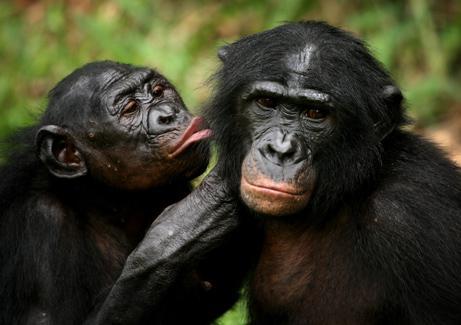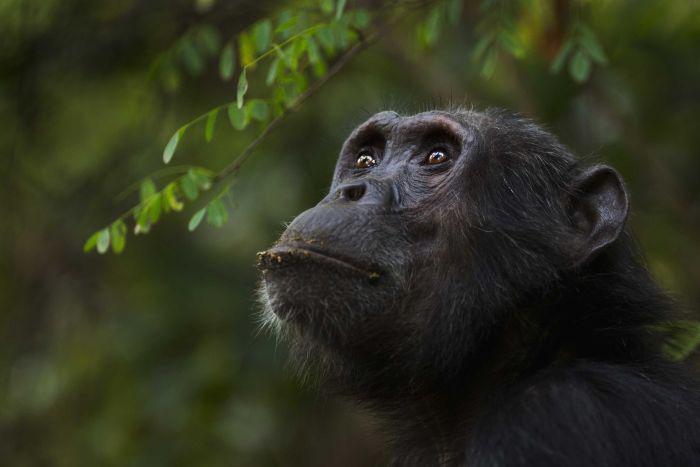The first image is the image on the left, the second image is the image on the right. Considering the images on both sides, is "Each image shows exactly two chimps sitting close together, and at least one image shows a chimp grooming the fur of the other." valid? Answer yes or no. No. The first image is the image on the left, the second image is the image on the right. Analyze the images presented: Is the assertion "The right image contains exactly two chimpanzees." valid? Answer yes or no. No. 